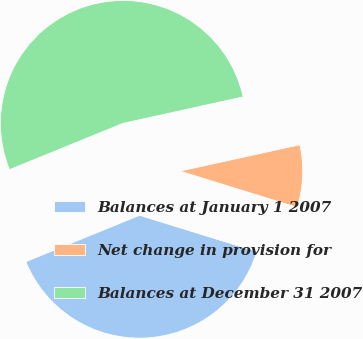<chart> <loc_0><loc_0><loc_500><loc_500><pie_chart><fcel>Balances at January 1 2007<fcel>Net change in provision for<fcel>Balances at December 31 2007<nl><fcel>39.06%<fcel>8.22%<fcel>52.72%<nl></chart> 